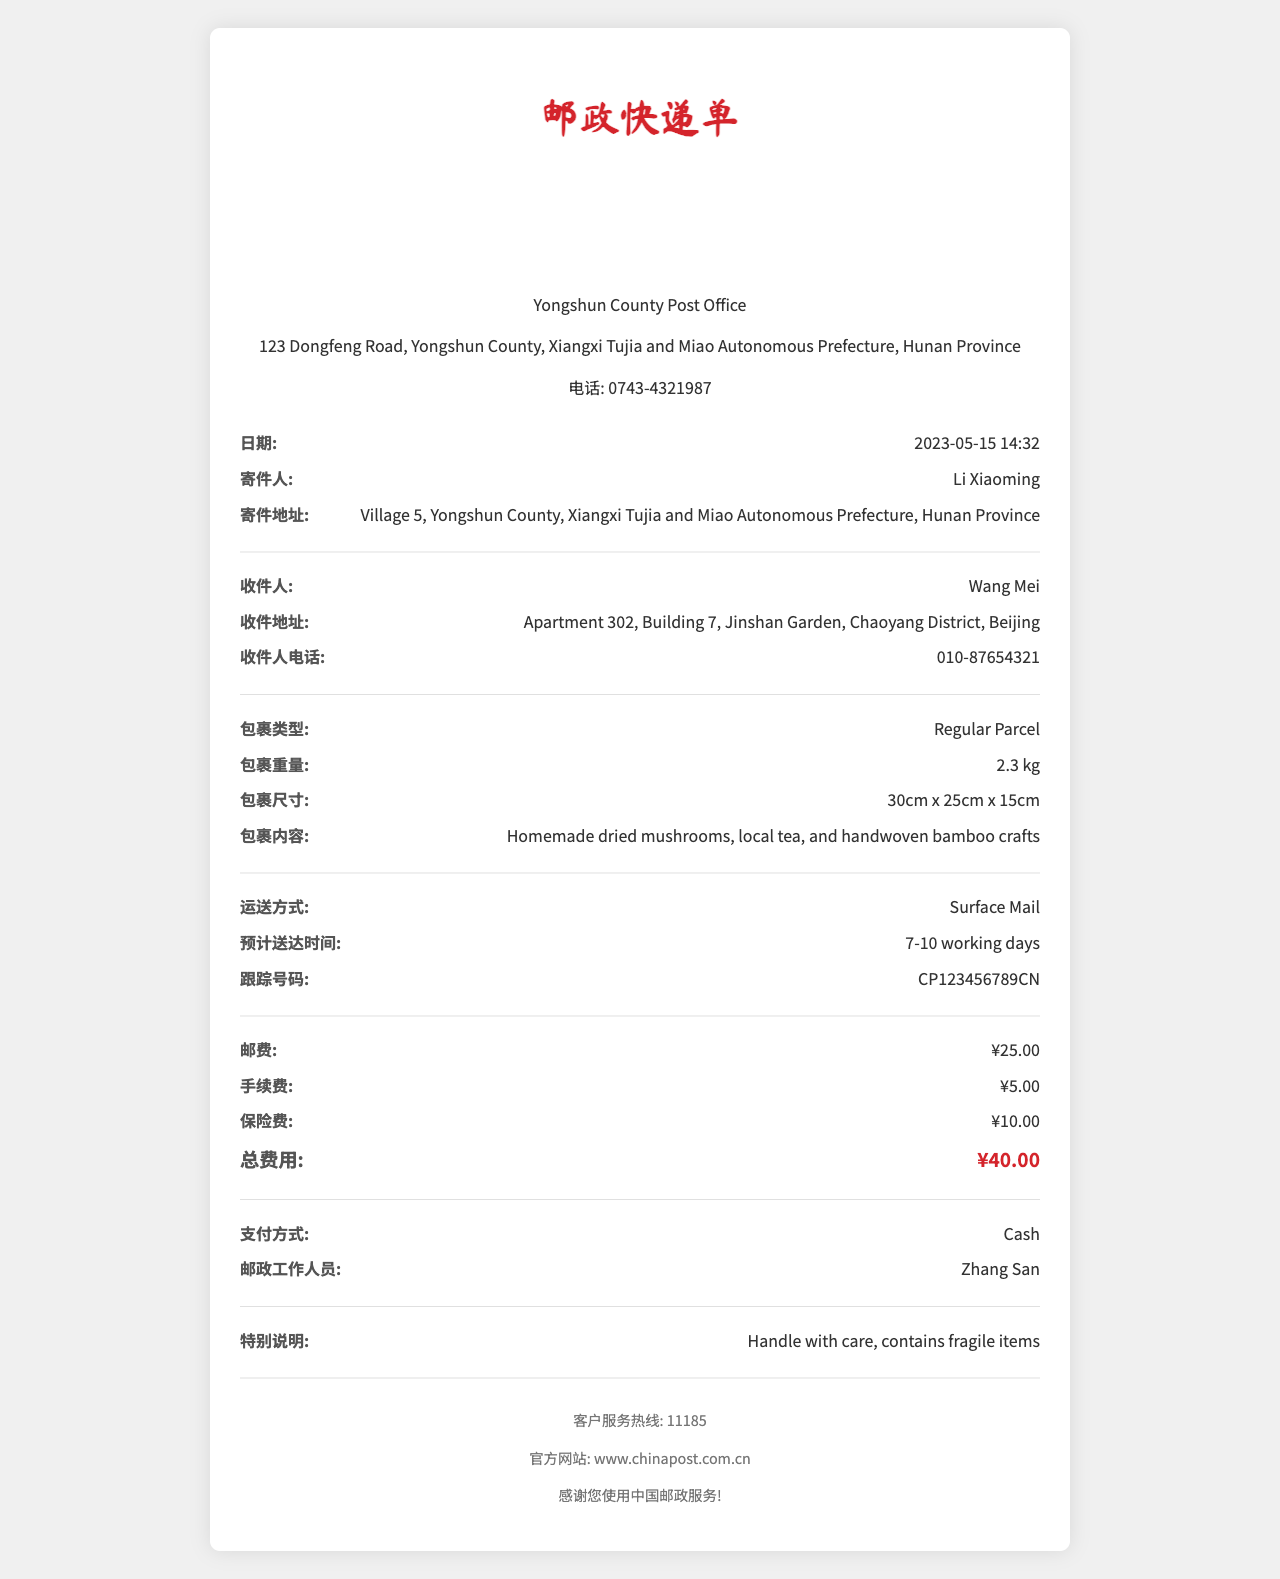What is the name of the post office? The name of the post office is provided at the top of the document, which is Yongshun County Post Office.
Answer: Yongshun County Post Office What is the date the package was sent? The date is found in the document under the date section, which states when the transaction took place, specifically on May 15, 2023.
Answer: 2023-05-15 Who is the recipient of the package? The recipient's name is listed in the document as the person receiving the package, which is Wang Mei.
Answer: Wang Mei What is the weight of the package? The weight of the package can be found in the specific section that details the package's characteristics, noted as 2.3 kg.
Answer: 2.3 kg What is the total fee for sending the package? The total fee is calculated by summing up various charges, explicitly stated in the document as ¥40.00.
Answer: ¥40.00 What shipping method was used? The shipping method is explicitly listed in the document, showing how the package was sent, which is Surface Mail.
Answer: Surface Mail How many working days is the estimated delivery time? The estimated delivery time is provided in the document, indicating how long it is anticipated to take, which is 7-10 working days.
Answer: 7-10 working days What special instructions were noted for the package? Special instructions are provided in the document regarding how to handle the package, which indicates that it contains fragile items and requires careful handling.
Answer: Handle with care, contains fragile items What payment method was used? The payment method is indicated in the appropriate section of the document, detailing how the payment was made, which is Cash.
Answer: Cash 